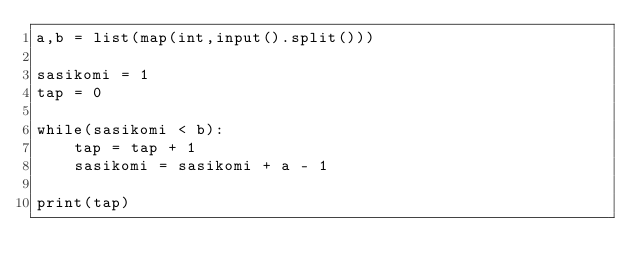Convert code to text. <code><loc_0><loc_0><loc_500><loc_500><_Python_>a,b = list(map(int,input().split()))

sasikomi = 1
tap = 0

while(sasikomi < b):
    tap = tap + 1
    sasikomi = sasikomi + a - 1

print(tap)
</code> 